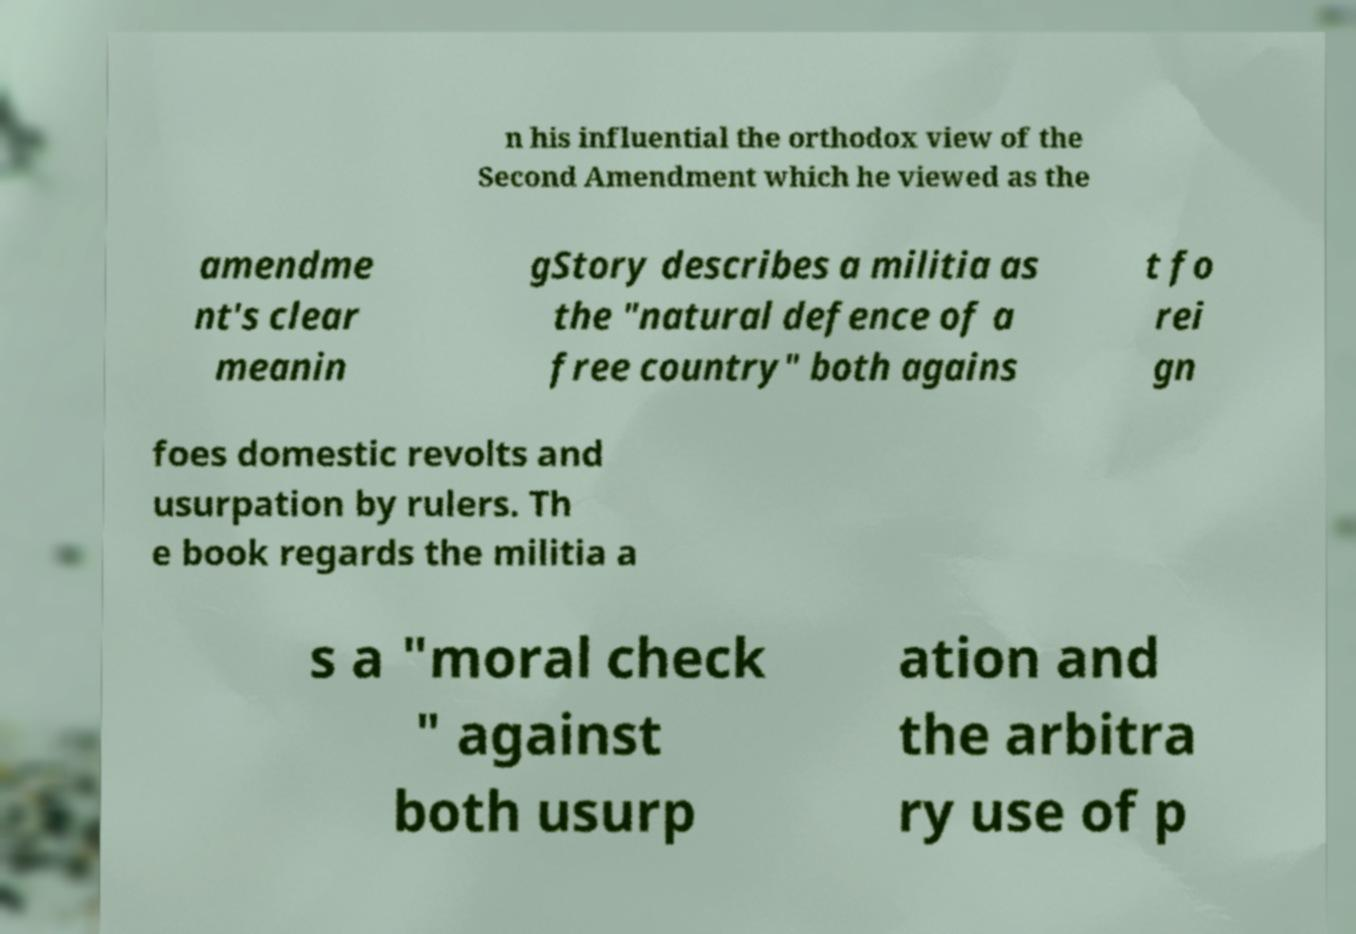What messages or text are displayed in this image? I need them in a readable, typed format. n his influential the orthodox view of the Second Amendment which he viewed as the amendme nt's clear meanin gStory describes a militia as the "natural defence of a free country" both agains t fo rei gn foes domestic revolts and usurpation by rulers. Th e book regards the militia a s a "moral check " against both usurp ation and the arbitra ry use of p 